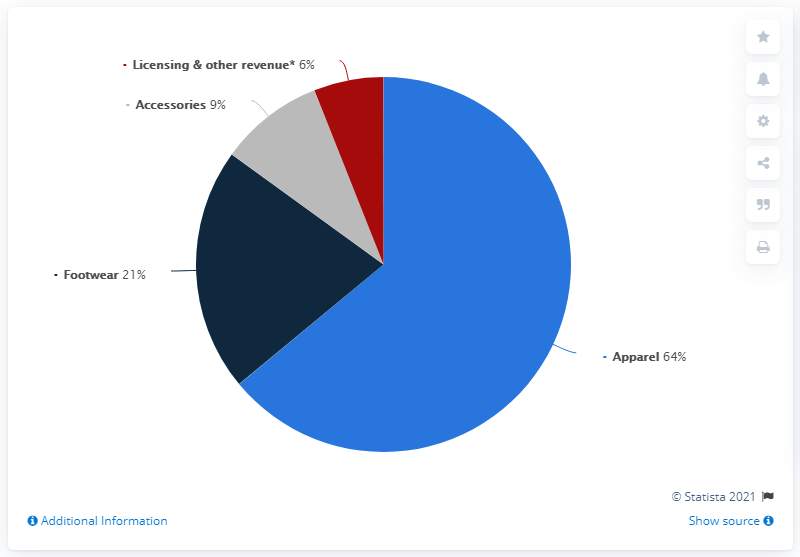Mention a couple of crucial points in this snapshot. The net sales of the maximum and minimum products sold under the Armour brand are currently 0.58 apart. According to the latest global apparel market share data, apparel products account for approximately 0.64% of the total retail market worldwide. 